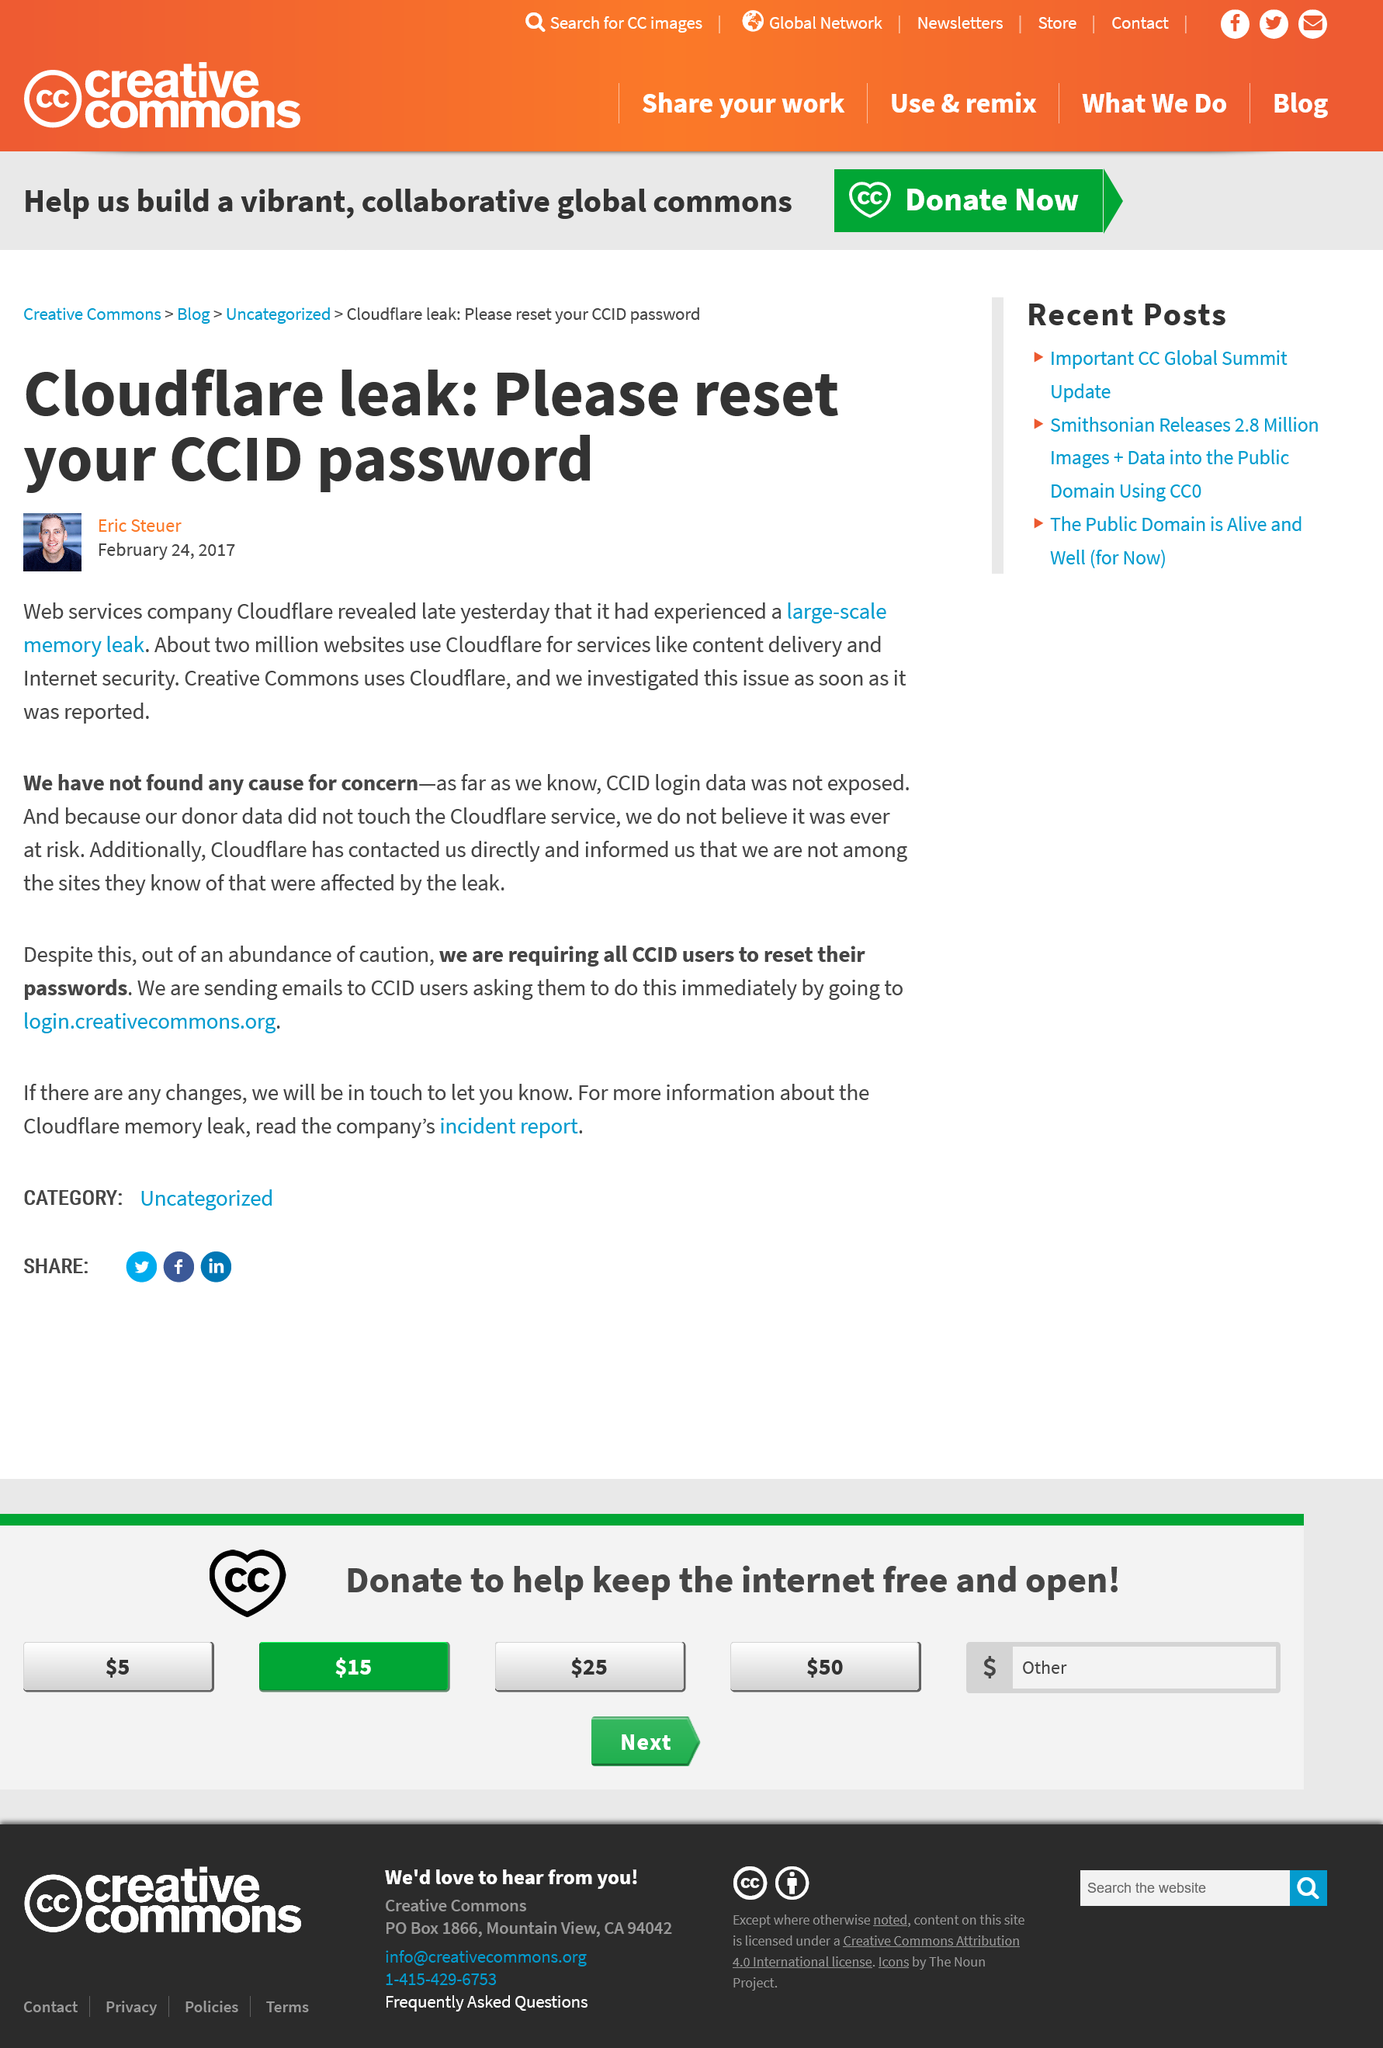Draw attention to some important aspects in this diagram. Creative Commons donor date does not affect Cloudflare services. Creative Commons uses Cloudflare. On February 23, 2017, Cloudflare publicly disclosed that it had experienced a large-scale memory leak. 